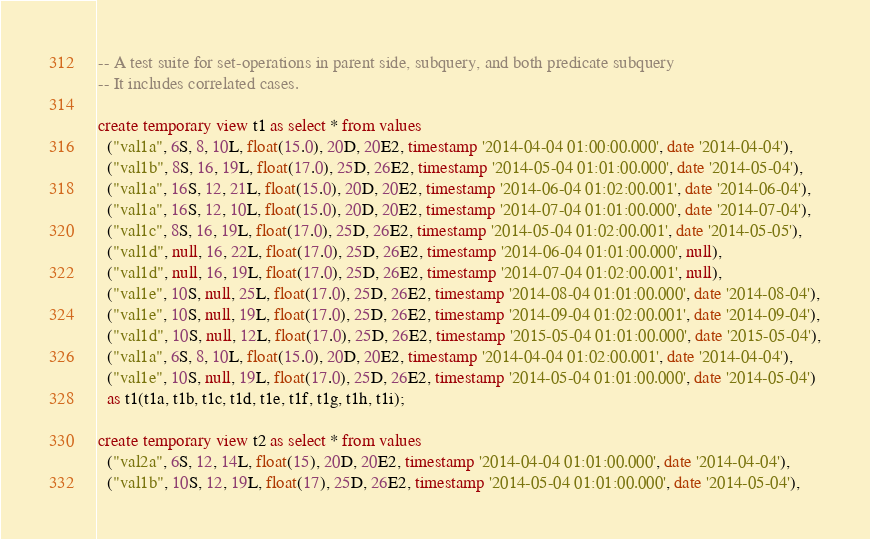<code> <loc_0><loc_0><loc_500><loc_500><_SQL_>-- A test suite for set-operations in parent side, subquery, and both predicate subquery
-- It includes correlated cases.

create temporary view t1 as select * from values
  ("val1a", 6S, 8, 10L, float(15.0), 20D, 20E2, timestamp '2014-04-04 01:00:00.000', date '2014-04-04'),
  ("val1b", 8S, 16, 19L, float(17.0), 25D, 26E2, timestamp '2014-05-04 01:01:00.000', date '2014-05-04'),
  ("val1a", 16S, 12, 21L, float(15.0), 20D, 20E2, timestamp '2014-06-04 01:02:00.001', date '2014-06-04'),
  ("val1a", 16S, 12, 10L, float(15.0), 20D, 20E2, timestamp '2014-07-04 01:01:00.000', date '2014-07-04'),
  ("val1c", 8S, 16, 19L, float(17.0), 25D, 26E2, timestamp '2014-05-04 01:02:00.001', date '2014-05-05'),
  ("val1d", null, 16, 22L, float(17.0), 25D, 26E2, timestamp '2014-06-04 01:01:00.000', null),
  ("val1d", null, 16, 19L, float(17.0), 25D, 26E2, timestamp '2014-07-04 01:02:00.001', null),
  ("val1e", 10S, null, 25L, float(17.0), 25D, 26E2, timestamp '2014-08-04 01:01:00.000', date '2014-08-04'),
  ("val1e", 10S, null, 19L, float(17.0), 25D, 26E2, timestamp '2014-09-04 01:02:00.001', date '2014-09-04'),
  ("val1d", 10S, null, 12L, float(17.0), 25D, 26E2, timestamp '2015-05-04 01:01:00.000', date '2015-05-04'),
  ("val1a", 6S, 8, 10L, float(15.0), 20D, 20E2, timestamp '2014-04-04 01:02:00.001', date '2014-04-04'),
  ("val1e", 10S, null, 19L, float(17.0), 25D, 26E2, timestamp '2014-05-04 01:01:00.000', date '2014-05-04')
  as t1(t1a, t1b, t1c, t1d, t1e, t1f, t1g, t1h, t1i);

create temporary view t2 as select * from values
  ("val2a", 6S, 12, 14L, float(15), 20D, 20E2, timestamp '2014-04-04 01:01:00.000', date '2014-04-04'),
  ("val1b", 10S, 12, 19L, float(17), 25D, 26E2, timestamp '2014-05-04 01:01:00.000', date '2014-05-04'),</code> 